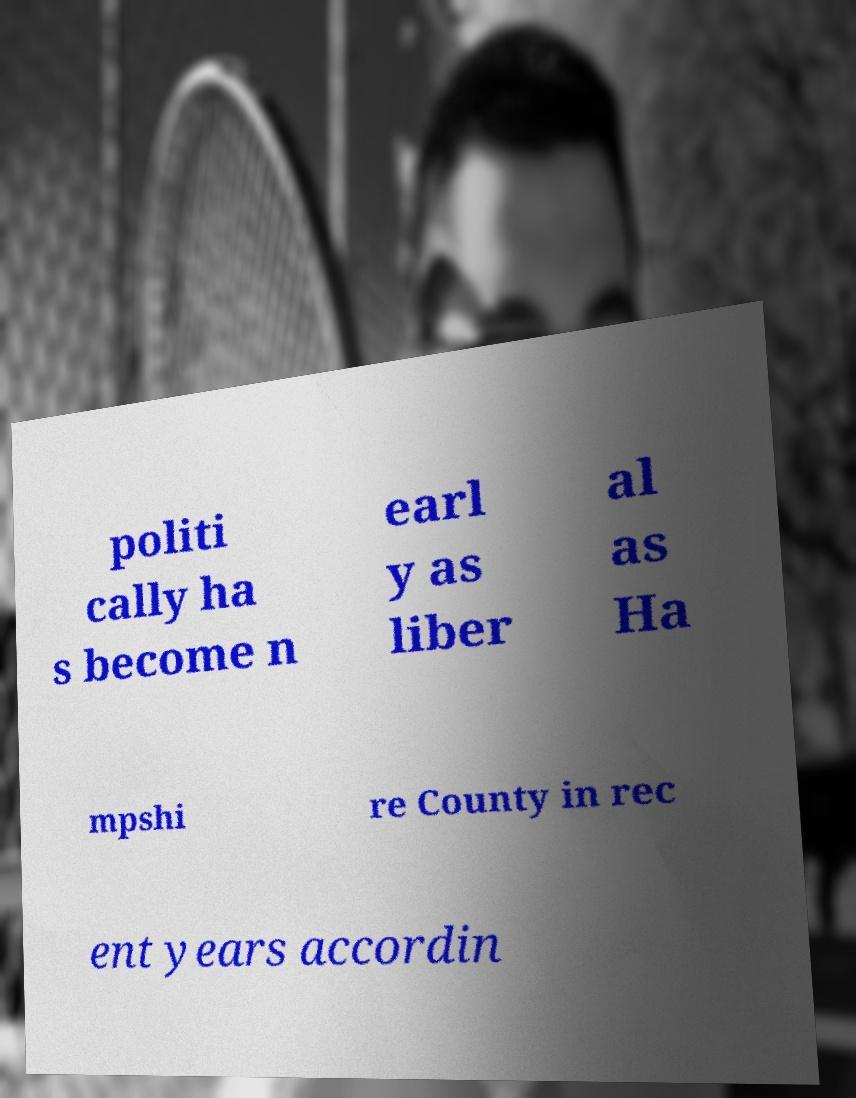Please read and relay the text visible in this image. What does it say? politi cally ha s become n earl y as liber al as Ha mpshi re County in rec ent years accordin 